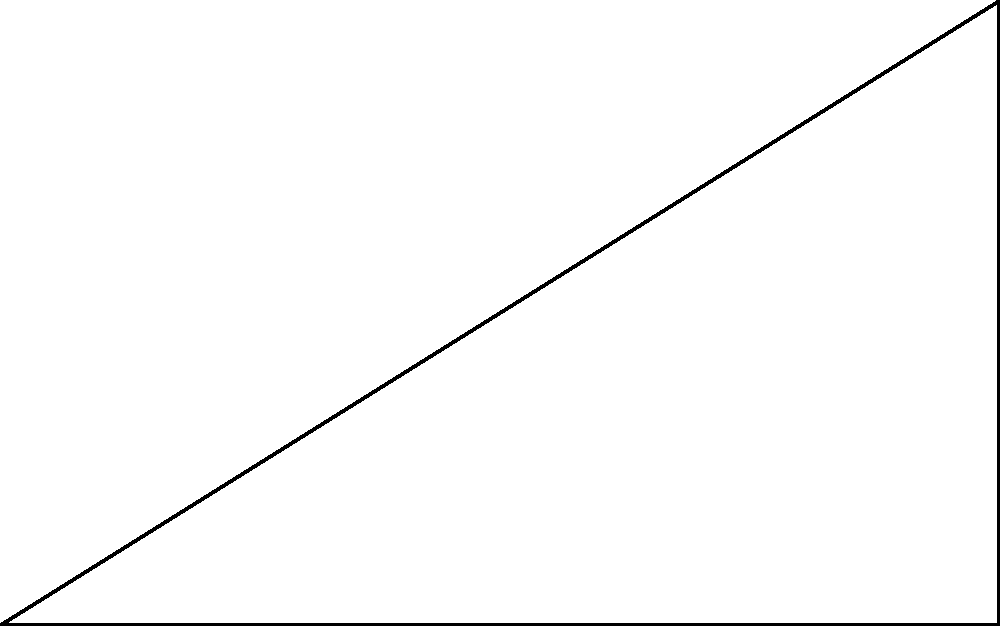The new church in your village has a tall steeple. To determine its height, you stand 30 meters away from the base and measure the angle of elevation to the top of the steeple to be 60°. Using this information, calculate the height of the church steeple. Let's approach this step-by-step:

1) We can represent this scenario as a right triangle, where:
   - The base of the triangle is the distance from you to the church (30 m)
   - The height of the triangle is the height of the steeple (what we're solving for)
   - The angle of elevation is 60°

2) In this right triangle, we know:
   - The adjacent side (base) = 30 m
   - The angle = 60°
   - We need to find the opposite side (height)

3) This is a perfect scenario to use the tangent function. Recall that:
   
   $$\tan(\theta) = \frac{\text{opposite}}{\text{adjacent}}$$

4) Plugging in our known values:

   $$\tan(60°) = \frac{\text{height}}{30}$$

5) We know that $\tan(60°) = \sqrt{3}$, so:

   $$\sqrt{3} = \frac{\text{height}}{30}$$

6) To solve for height, multiply both sides by 30:

   $$30\sqrt{3} = \text{height}$$

7) Simplify:
   
   $$\text{height} \approx 51.96 \text{ meters}$$

Therefore, the height of the church steeple is approximately 51.96 meters.
Answer: 51.96 meters 